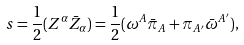<formula> <loc_0><loc_0><loc_500><loc_500>s = \frac { 1 } { 2 } ( Z ^ { \alpha } \bar { Z } _ { \alpha } ) = \frac { 1 } { 2 } ( \omega ^ { A } \bar { \pi } _ { A } + \pi _ { A ^ { \prime } } \bar { \omega } ^ { A ^ { \prime } } ) ,</formula> 